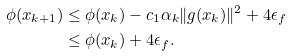<formula> <loc_0><loc_0><loc_500><loc_500>\phi ( x _ { k + 1 } ) & \leq \phi ( x _ { k } ) - c _ { 1 } \alpha _ { k } \| g ( x _ { k } ) \| ^ { 2 } + 4 \epsilon _ { f } \\ & \leq \phi ( x _ { k } ) + 4 \epsilon _ { f } .</formula> 